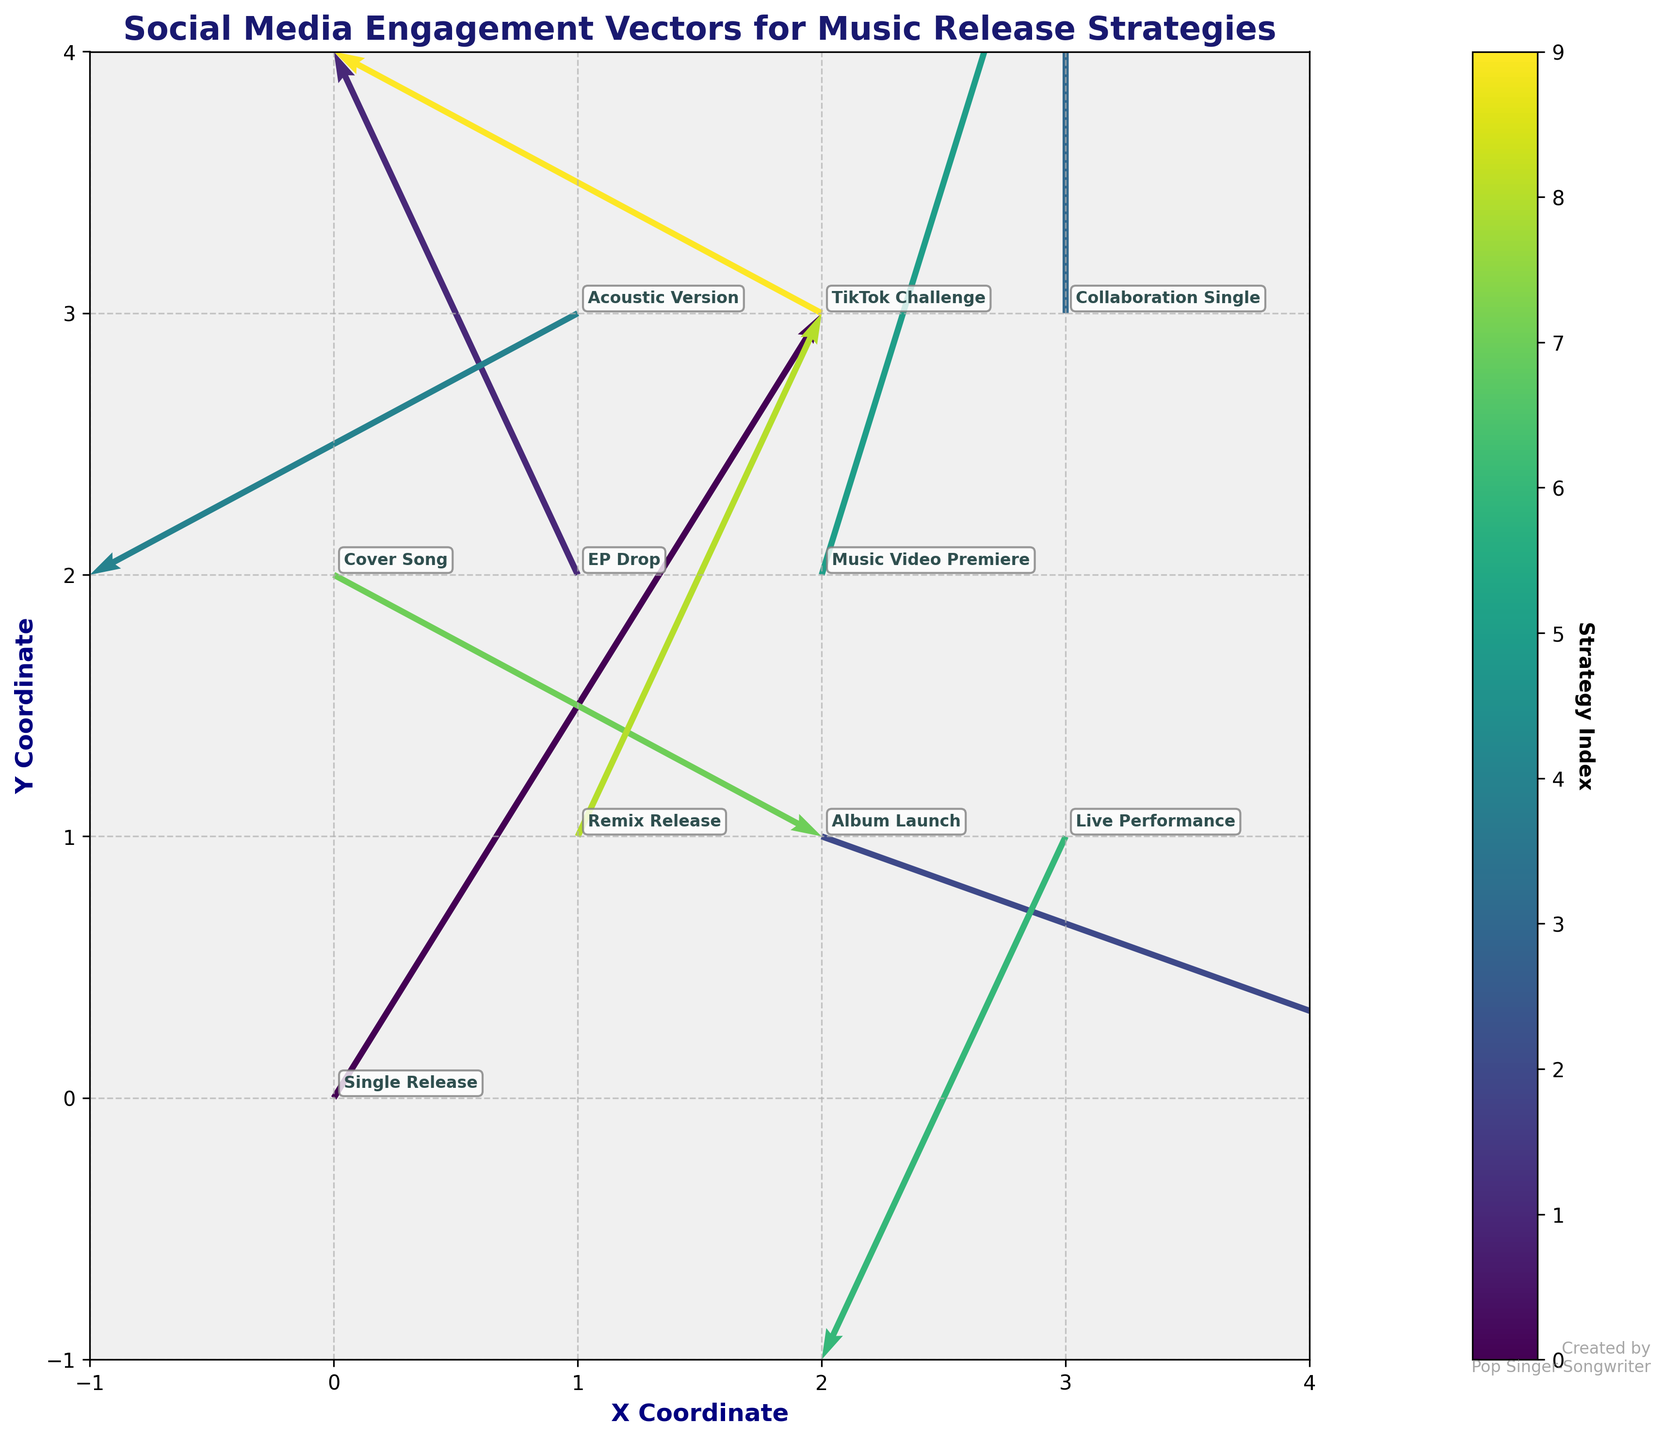What is the title of the figure? The title is typically located at the top of the figure. In this case, it states "Social Media Engagement Vectors for Music Release Strategies."
Answer: Social Media Engagement Vectors for Music Release Strategies How many music release strategies are shown in the quiver plot? To determine the number of strategies, count the number of unique annotations. In this plot, there are ten different strategies listed.
Answer: 10 What are the x and y coordinates of the "Single Release" strategy? By examining the plot and looking for the label "Single Release," we see it is located at coordinates (0,0).
Answer: (0, 0) Which strategy has the longest vector in the plot? The vector length can be estimated visually by looking for the arrows with the greatest magnitude (u^2 + v^2). The "Single Release" strategy appears to have one of the longest vectors, moving from (0, 0) with components (2, 3), giving a magnitude of √(2^2 + 3^2).
Answer: Single Release Which strategies result in a negative y-component in their vectors? To identify strategies with a negative y-component, look for arrows pointing downward. The "Album Launch," "Acoustic Version," "Cover Song," and "Live Performance" strategies have vectors with negative y-components.
Answer: Album Launch, Acoustic Version, Cover Song, Live Performance How do the vectors for "TikTok Challenge" and "EP Drop" compare in terms of direction? Compare their end points by moving from their starting points along their vectors. "TikTok Challenge" moves left and slightly upwards while "EP Drop" moves left and upwards. Both have a negative x-component but different y-components.
Answer: Similar direction What is the next position for the "Collaboration Single" strategy's engagement vector? Starting from (3,3) with vector (0,2), the next position coordinates can be calculated as (3+0, 3+2) = (3, 5).
Answer: (3, 5) Which strategy has the closest engagement vector orientation to the "Remix Release"? "Remix Release" has a vector (1,2). Compare directional angles of other vectors. "EP Drop" with vector (-1, 2) also moves upwards and horizontally, closely matching the "Remix Release".
Answer: EP Drop What is the coordinate range covering all engagement vectors in the plot? By observing the maximum and minimum x and y values, the range can be determined from the data points. The x range is from -1 to 4, and the y range is from -1 to 4.
Answer: x: -1 to 4, y: -1 to 4 